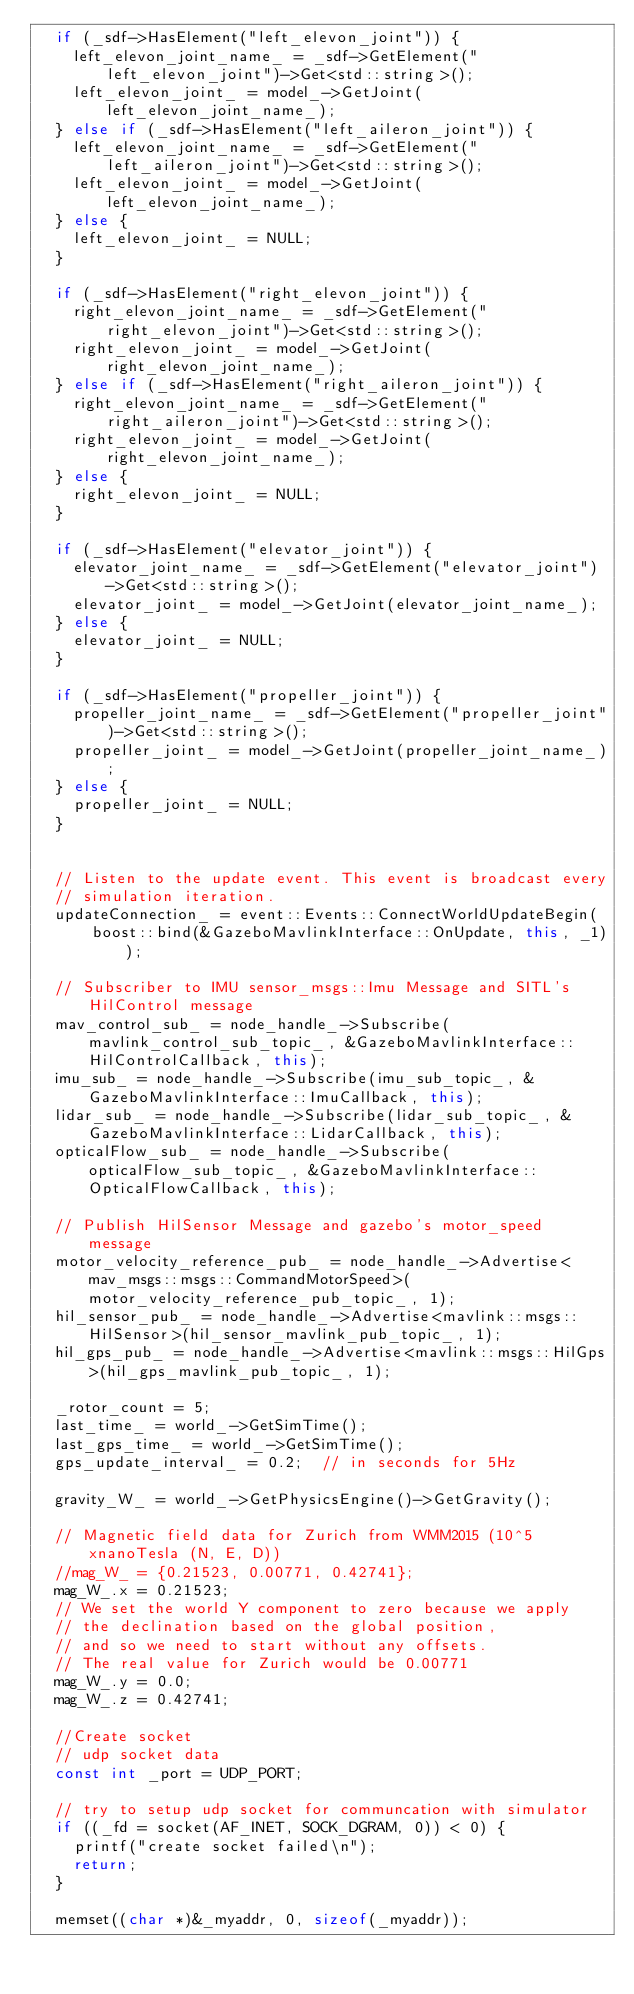Convert code to text. <code><loc_0><loc_0><loc_500><loc_500><_C++_>  if (_sdf->HasElement("left_elevon_joint")) {
    left_elevon_joint_name_ = _sdf->GetElement("left_elevon_joint")->Get<std::string>();
    left_elevon_joint_ = model_->GetJoint(left_elevon_joint_name_);
  } else if (_sdf->HasElement("left_aileron_joint")) {
    left_elevon_joint_name_ = _sdf->GetElement("left_aileron_joint")->Get<std::string>();
    left_elevon_joint_ = model_->GetJoint(left_elevon_joint_name_);
  } else {
    left_elevon_joint_ = NULL;
  }

  if (_sdf->HasElement("right_elevon_joint")) {
    right_elevon_joint_name_ = _sdf->GetElement("right_elevon_joint")->Get<std::string>();
    right_elevon_joint_ = model_->GetJoint(right_elevon_joint_name_);
  } else if (_sdf->HasElement("right_aileron_joint")) {
    right_elevon_joint_name_ = _sdf->GetElement("right_aileron_joint")->Get<std::string>();
    right_elevon_joint_ = model_->GetJoint(right_elevon_joint_name_);
  } else {
    right_elevon_joint_ = NULL;
  }

  if (_sdf->HasElement("elevator_joint")) {
    elevator_joint_name_ = _sdf->GetElement("elevator_joint")->Get<std::string>();
    elevator_joint_ = model_->GetJoint(elevator_joint_name_);
  } else {
    elevator_joint_ = NULL;
  }

  if (_sdf->HasElement("propeller_joint")) {
    propeller_joint_name_ = _sdf->GetElement("propeller_joint")->Get<std::string>();
    propeller_joint_ = model_->GetJoint(propeller_joint_name_);
  } else {
    propeller_joint_ = NULL;
  }


  // Listen to the update event. This event is broadcast every
  // simulation iteration.
  updateConnection_ = event::Events::ConnectWorldUpdateBegin(
      boost::bind(&GazeboMavlinkInterface::OnUpdate, this, _1));

  // Subscriber to IMU sensor_msgs::Imu Message and SITL's HilControl message
  mav_control_sub_ = node_handle_->Subscribe(mavlink_control_sub_topic_, &GazeboMavlinkInterface::HilControlCallback, this);
  imu_sub_ = node_handle_->Subscribe(imu_sub_topic_, &GazeboMavlinkInterface::ImuCallback, this);
  lidar_sub_ = node_handle_->Subscribe(lidar_sub_topic_, &GazeboMavlinkInterface::LidarCallback, this);
  opticalFlow_sub_ = node_handle_->Subscribe(opticalFlow_sub_topic_, &GazeboMavlinkInterface::OpticalFlowCallback, this);

  // Publish HilSensor Message and gazebo's motor_speed message
  motor_velocity_reference_pub_ = node_handle_->Advertise<mav_msgs::msgs::CommandMotorSpeed>(motor_velocity_reference_pub_topic_, 1);
  hil_sensor_pub_ = node_handle_->Advertise<mavlink::msgs::HilSensor>(hil_sensor_mavlink_pub_topic_, 1);
  hil_gps_pub_ = node_handle_->Advertise<mavlink::msgs::HilGps>(hil_gps_mavlink_pub_topic_, 1);

  _rotor_count = 5;
  last_time_ = world_->GetSimTime();
  last_gps_time_ = world_->GetSimTime();
  gps_update_interval_ = 0.2;  // in seconds for 5Hz

  gravity_W_ = world_->GetPhysicsEngine()->GetGravity();

  // Magnetic field data for Zurich from WMM2015 (10^5xnanoTesla (N, E, D))
  //mag_W_ = {0.21523, 0.00771, 0.42741};
  mag_W_.x = 0.21523;
  // We set the world Y component to zero because we apply
  // the declination based on the global position,
  // and so we need to start without any offsets.
  // The real value for Zurich would be 0.00771
  mag_W_.y = 0.0;
  mag_W_.z = 0.42741;

  //Create socket
  // udp socket data
  const int _port = UDP_PORT;

  // try to setup udp socket for communcation with simulator
  if ((_fd = socket(AF_INET, SOCK_DGRAM, 0)) < 0) {
    printf("create socket failed\n");
    return;
  }

  memset((char *)&_myaddr, 0, sizeof(_myaddr));</code> 